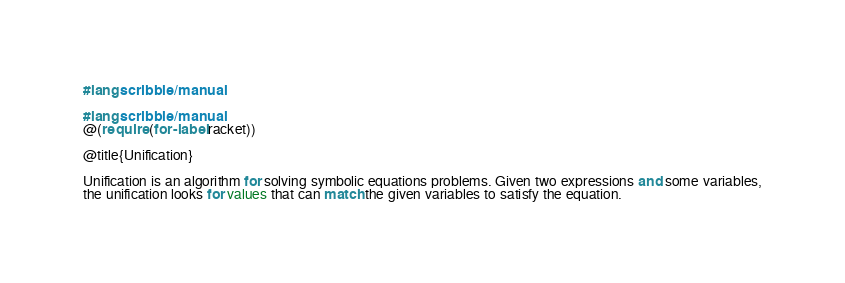Convert code to text. <code><loc_0><loc_0><loc_500><loc_500><_Racket_>#lang scribble/manual

#lang scribble/manual
@(require (for-label racket))

@title{Unification}

Unification is an algorithm for solving symbolic equations problems. Given two expressions and some variables,
the unification looks for values that can match the given variables to satisfy the equation.</code> 